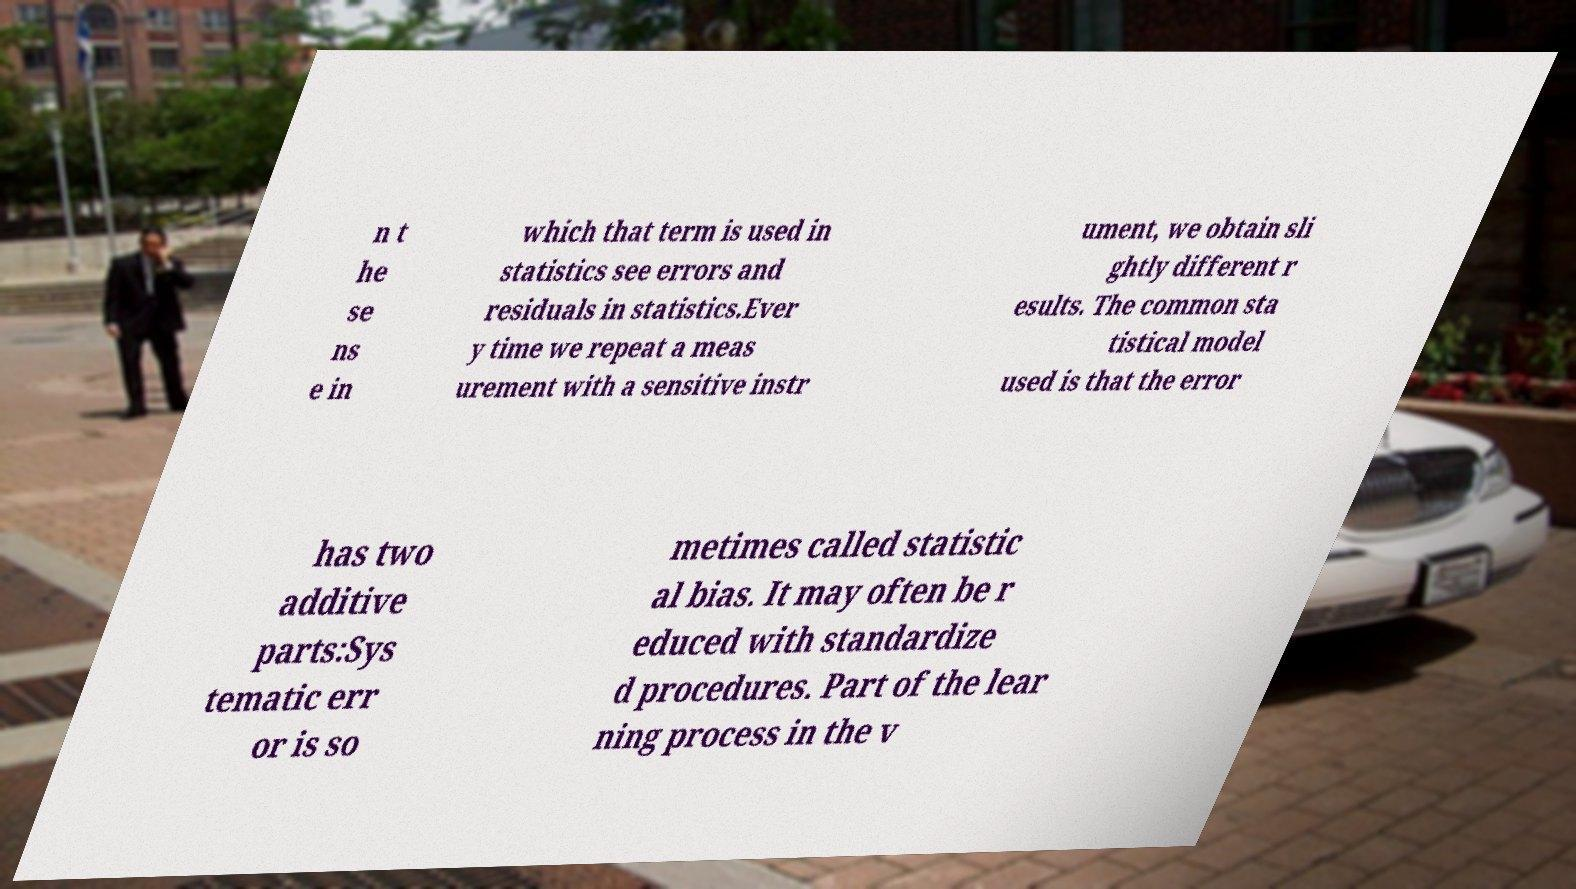For documentation purposes, I need the text within this image transcribed. Could you provide that? n t he se ns e in which that term is used in statistics see errors and residuals in statistics.Ever y time we repeat a meas urement with a sensitive instr ument, we obtain sli ghtly different r esults. The common sta tistical model used is that the error has two additive parts:Sys tematic err or is so metimes called statistic al bias. It may often be r educed with standardize d procedures. Part of the lear ning process in the v 